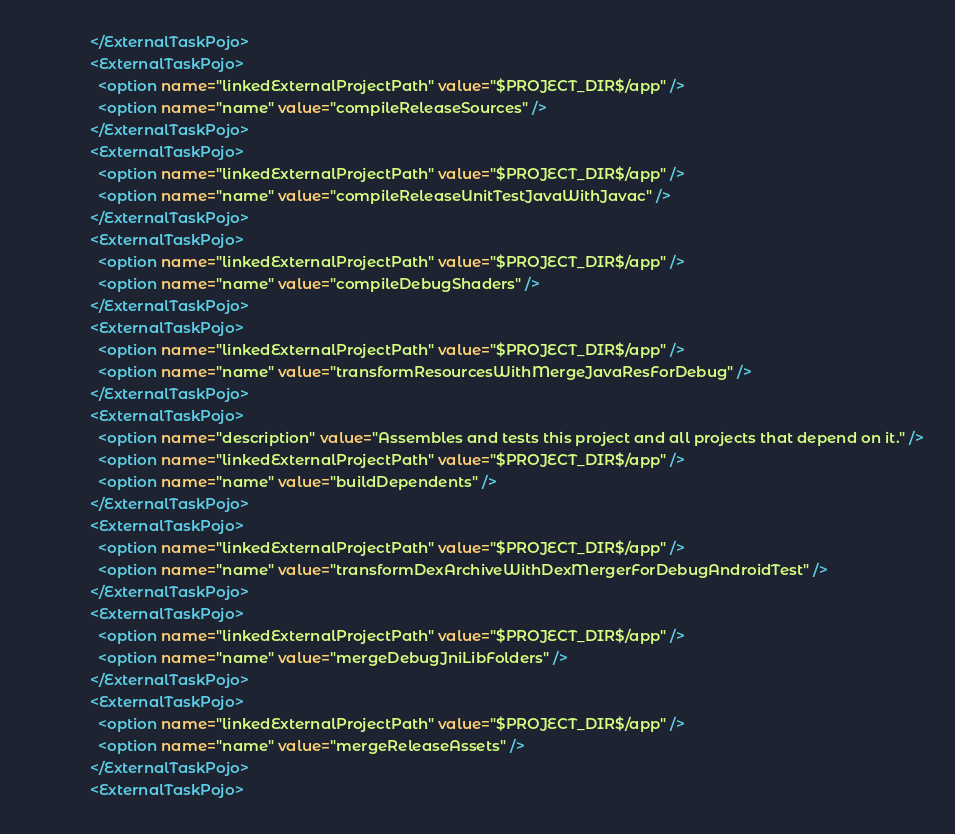Convert code to text. <code><loc_0><loc_0><loc_500><loc_500><_XML_>              </ExternalTaskPojo>
              <ExternalTaskPojo>
                <option name="linkedExternalProjectPath" value="$PROJECT_DIR$/app" />
                <option name="name" value="compileReleaseSources" />
              </ExternalTaskPojo>
              <ExternalTaskPojo>
                <option name="linkedExternalProjectPath" value="$PROJECT_DIR$/app" />
                <option name="name" value="compileReleaseUnitTestJavaWithJavac" />
              </ExternalTaskPojo>
              <ExternalTaskPojo>
                <option name="linkedExternalProjectPath" value="$PROJECT_DIR$/app" />
                <option name="name" value="compileDebugShaders" />
              </ExternalTaskPojo>
              <ExternalTaskPojo>
                <option name="linkedExternalProjectPath" value="$PROJECT_DIR$/app" />
                <option name="name" value="transformResourcesWithMergeJavaResForDebug" />
              </ExternalTaskPojo>
              <ExternalTaskPojo>
                <option name="description" value="Assembles and tests this project and all projects that depend on it." />
                <option name="linkedExternalProjectPath" value="$PROJECT_DIR$/app" />
                <option name="name" value="buildDependents" />
              </ExternalTaskPojo>
              <ExternalTaskPojo>
                <option name="linkedExternalProjectPath" value="$PROJECT_DIR$/app" />
                <option name="name" value="transformDexArchiveWithDexMergerForDebugAndroidTest" />
              </ExternalTaskPojo>
              <ExternalTaskPojo>
                <option name="linkedExternalProjectPath" value="$PROJECT_DIR$/app" />
                <option name="name" value="mergeDebugJniLibFolders" />
              </ExternalTaskPojo>
              <ExternalTaskPojo>
                <option name="linkedExternalProjectPath" value="$PROJECT_DIR$/app" />
                <option name="name" value="mergeReleaseAssets" />
              </ExternalTaskPojo>
              <ExternalTaskPojo></code> 